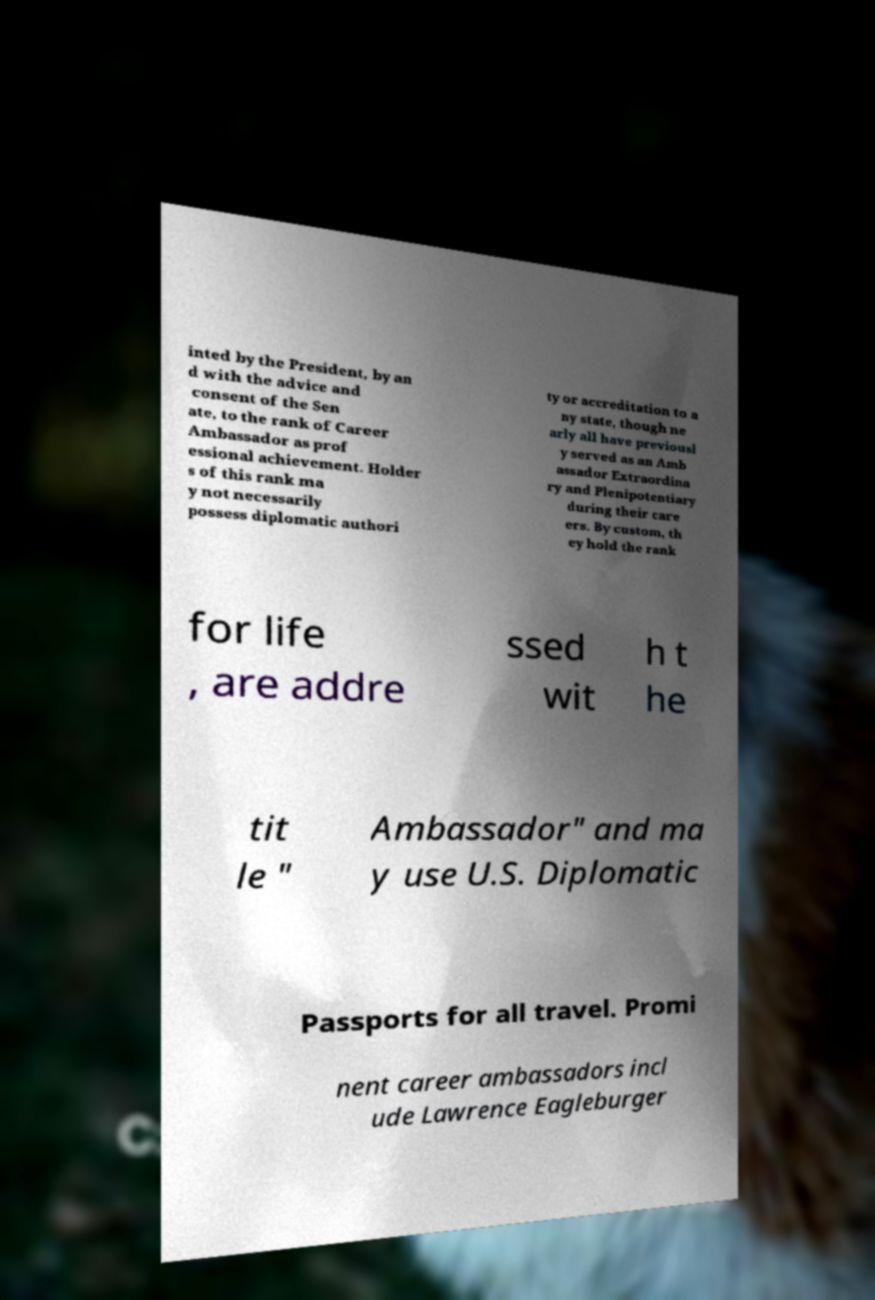Can you accurately transcribe the text from the provided image for me? inted by the President, by an d with the advice and consent of the Sen ate, to the rank of Career Ambassador as prof essional achievement. Holder s of this rank ma y not necessarily possess diplomatic authori ty or accreditation to a ny state, though ne arly all have previousl y served as an Amb assador Extraordina ry and Plenipotentiary during their care ers. By custom, th ey hold the rank for life , are addre ssed wit h t he tit le " Ambassador" and ma y use U.S. Diplomatic Passports for all travel. Promi nent career ambassadors incl ude Lawrence Eagleburger 